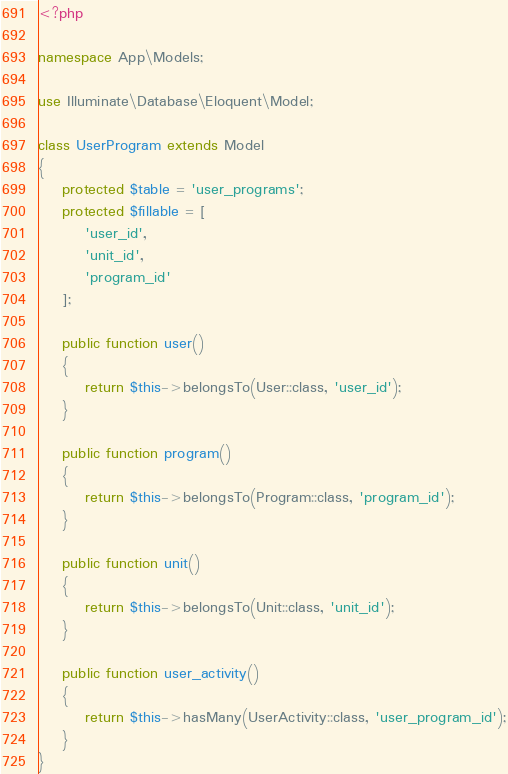Convert code to text. <code><loc_0><loc_0><loc_500><loc_500><_PHP_><?php

namespace App\Models;

use Illuminate\Database\Eloquent\Model;

class UserProgram extends Model
{
    protected $table = 'user_programs';
    protected $fillable = [
        'user_id',
        'unit_id',
        'program_id'
    ];

    public function user() 
    {
        return $this->belongsTo(User::class, 'user_id');
    }

    public function program()
    {
        return $this->belongsTo(Program::class, 'program_id');
    }

    public function unit()
    {
        return $this->belongsTo(Unit::class, 'unit_id');
    }

    public function user_activity()
    {
        return $this->hasMany(UserActivity::class, 'user_program_id');
    }
}
</code> 